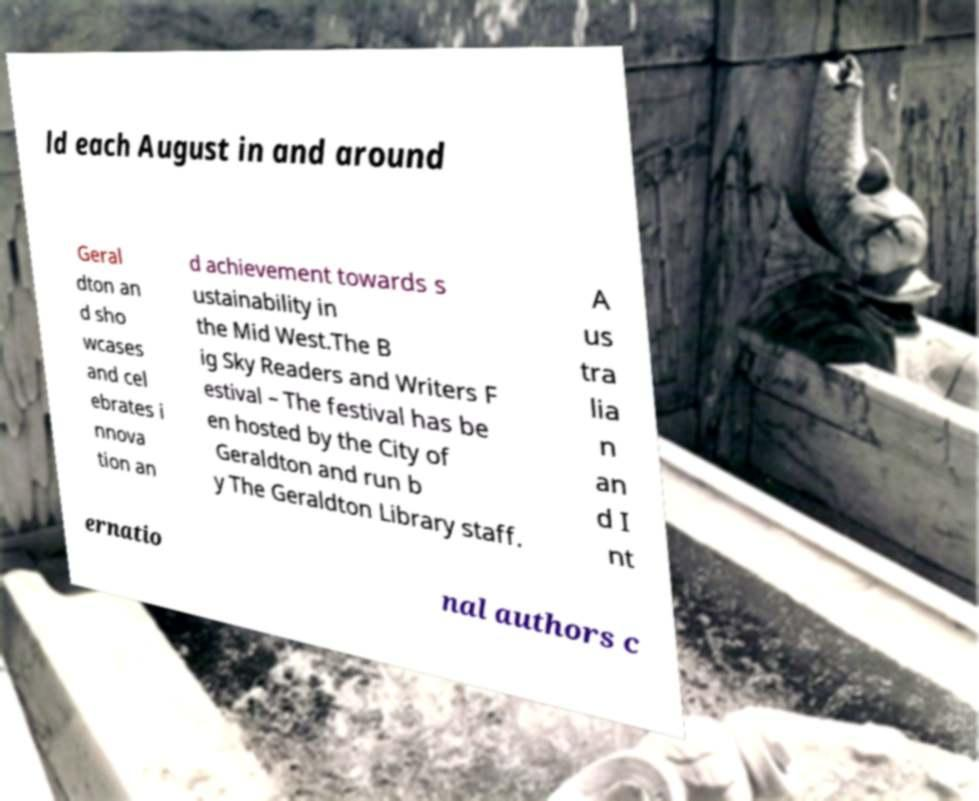Please identify and transcribe the text found in this image. ld each August in and around Geral dton an d sho wcases and cel ebrates i nnova tion an d achievement towards s ustainability in the Mid West.The B ig Sky Readers and Writers F estival – The festival has be en hosted by the City of Geraldton and run b y The Geraldton Library staff. A us tra lia n an d I nt ernatio nal authors c 